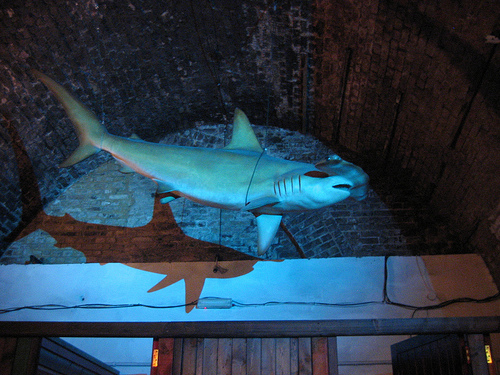<image>
Can you confirm if the shark is above the beam? Yes. The shark is positioned above the beam in the vertical space, higher up in the scene. Is there a shark on the wall? No. The shark is not positioned on the wall. They may be near each other, but the shark is not supported by or resting on top of the wall. Is the shadow in front of the shark? No. The shadow is not in front of the shark. The spatial positioning shows a different relationship between these objects. 